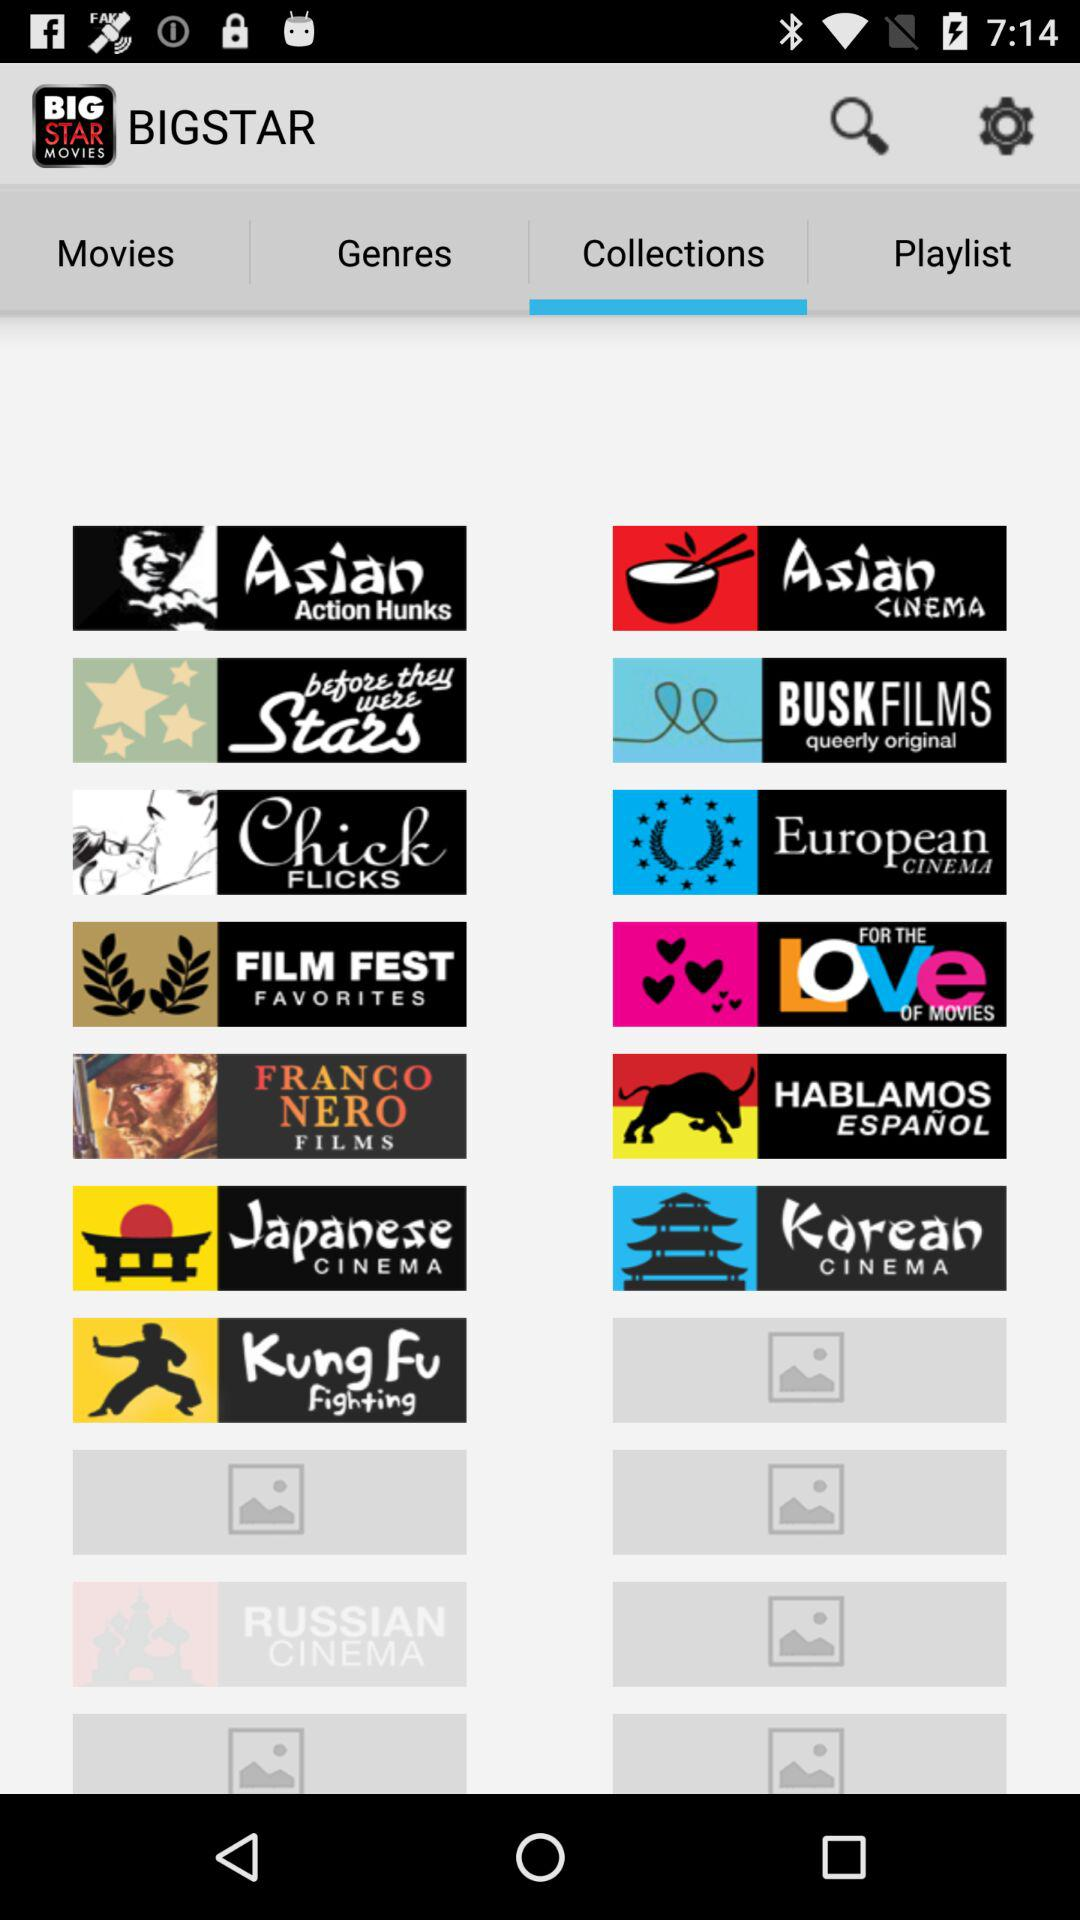Which is the selected option under "BIGSTAR"? The selected option is "Collections". 